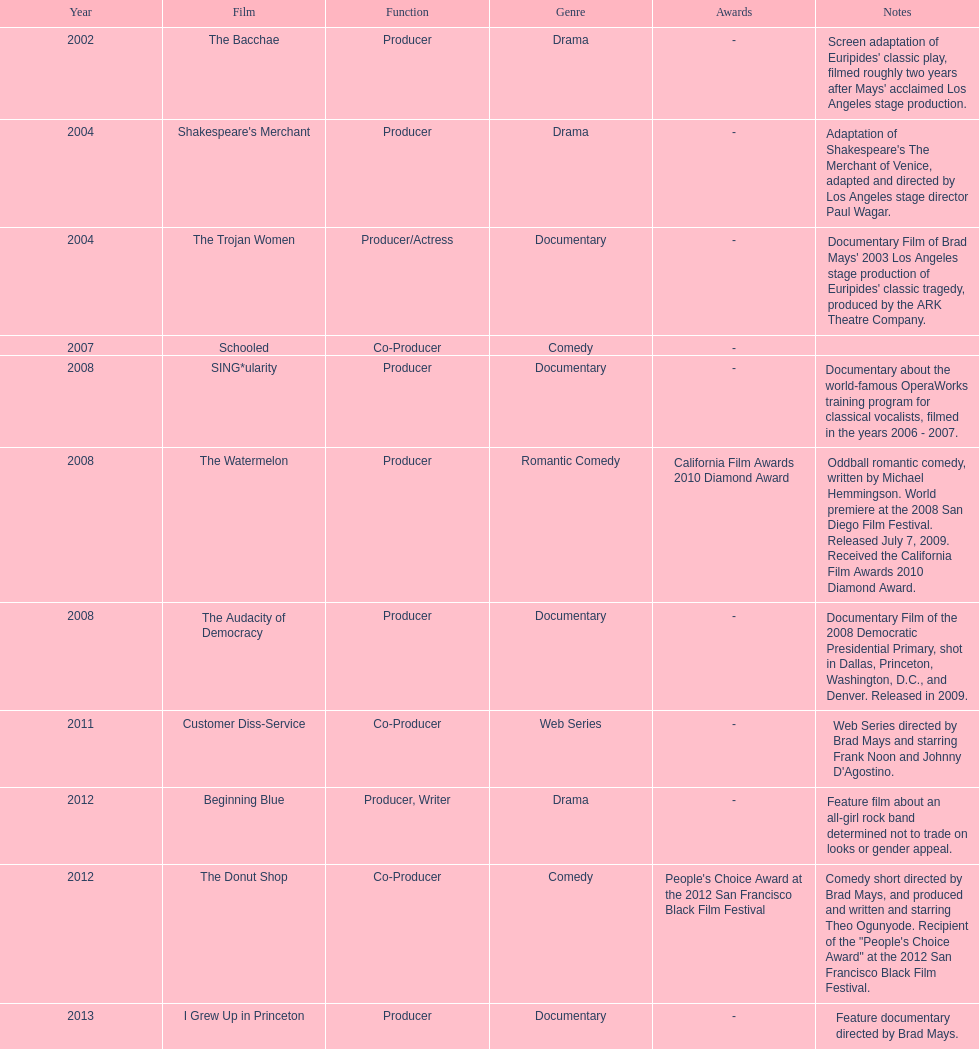How many films did ms. starfelt produce after 2010? 4. 